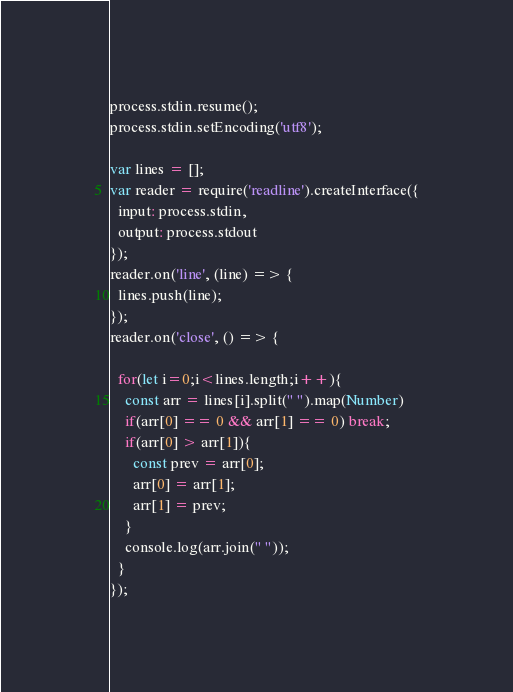Convert code to text. <code><loc_0><loc_0><loc_500><loc_500><_JavaScript_>process.stdin.resume();
process.stdin.setEncoding('utf8');

var lines = [];
var reader = require('readline').createInterface({
  input: process.stdin,
  output: process.stdout
});
reader.on('line', (line) => {
  lines.push(line);
});
reader.on('close', () => {
  
  for(let i=0;i<lines.length;i++){
    const arr = lines[i].split(" ").map(Number)
    if(arr[0] == 0 && arr[1] == 0) break;
    if(arr[0] > arr[1]){
      const prev = arr[0];
      arr[0] = arr[1];
      arr[1] = prev;
    }
    console.log(arr.join(" "));
  }
});
</code> 